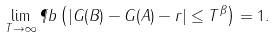<formula> <loc_0><loc_0><loc_500><loc_500>\lim _ { T \to \infty } \P b \left ( | G ( B ) - G ( A ) - r | \leq T ^ { \beta } \right ) = 1 .</formula> 